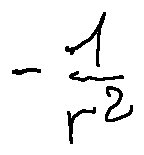Convert formula to latex. <formula><loc_0><loc_0><loc_500><loc_500>- \frac { 1 } { r ^ { 2 } }</formula> 